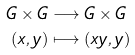<formula> <loc_0><loc_0><loc_500><loc_500>G \times G & \longrightarrow G \times G \\ ( x , y ) & \longmapsto ( x y , y )</formula> 